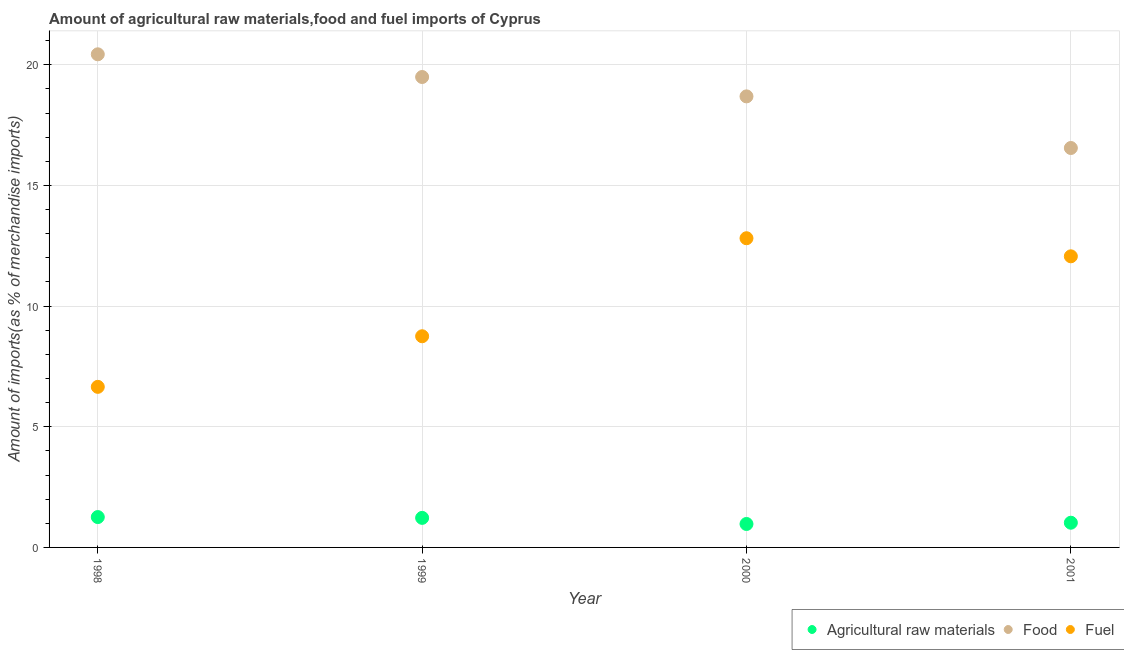Is the number of dotlines equal to the number of legend labels?
Your response must be concise. Yes. What is the percentage of fuel imports in 1999?
Give a very brief answer. 8.75. Across all years, what is the maximum percentage of food imports?
Offer a terse response. 20.43. Across all years, what is the minimum percentage of food imports?
Your response must be concise. 16.55. What is the total percentage of fuel imports in the graph?
Offer a terse response. 40.28. What is the difference between the percentage of raw materials imports in 1998 and that in 2000?
Offer a very short reply. 0.29. What is the difference between the percentage of raw materials imports in 1999 and the percentage of fuel imports in 2000?
Provide a succinct answer. -11.59. What is the average percentage of raw materials imports per year?
Provide a short and direct response. 1.12. In the year 1998, what is the difference between the percentage of raw materials imports and percentage of food imports?
Offer a very short reply. -19.18. In how many years, is the percentage of raw materials imports greater than 4 %?
Provide a succinct answer. 0. What is the ratio of the percentage of raw materials imports in 1999 to that in 2000?
Offer a terse response. 1.26. What is the difference between the highest and the second highest percentage of raw materials imports?
Your answer should be very brief. 0.03. What is the difference between the highest and the lowest percentage of fuel imports?
Your answer should be compact. 6.16. In how many years, is the percentage of fuel imports greater than the average percentage of fuel imports taken over all years?
Provide a succinct answer. 2. How many dotlines are there?
Your answer should be compact. 3. How many years are there in the graph?
Your response must be concise. 4. Are the values on the major ticks of Y-axis written in scientific E-notation?
Offer a very short reply. No. Does the graph contain grids?
Give a very brief answer. Yes. Where does the legend appear in the graph?
Your answer should be very brief. Bottom right. How many legend labels are there?
Make the answer very short. 3. What is the title of the graph?
Keep it short and to the point. Amount of agricultural raw materials,food and fuel imports of Cyprus. Does "Maunufacturing" appear as one of the legend labels in the graph?
Provide a short and direct response. No. What is the label or title of the X-axis?
Offer a terse response. Year. What is the label or title of the Y-axis?
Ensure brevity in your answer.  Amount of imports(as % of merchandise imports). What is the Amount of imports(as % of merchandise imports) in Agricultural raw materials in 1998?
Make the answer very short. 1.26. What is the Amount of imports(as % of merchandise imports) in Food in 1998?
Make the answer very short. 20.43. What is the Amount of imports(as % of merchandise imports) in Fuel in 1998?
Give a very brief answer. 6.65. What is the Amount of imports(as % of merchandise imports) of Agricultural raw materials in 1999?
Make the answer very short. 1.22. What is the Amount of imports(as % of merchandise imports) of Food in 1999?
Offer a very short reply. 19.49. What is the Amount of imports(as % of merchandise imports) of Fuel in 1999?
Make the answer very short. 8.75. What is the Amount of imports(as % of merchandise imports) in Agricultural raw materials in 2000?
Provide a short and direct response. 0.97. What is the Amount of imports(as % of merchandise imports) of Food in 2000?
Your answer should be compact. 18.69. What is the Amount of imports(as % of merchandise imports) of Fuel in 2000?
Offer a terse response. 12.81. What is the Amount of imports(as % of merchandise imports) in Agricultural raw materials in 2001?
Offer a very short reply. 1.02. What is the Amount of imports(as % of merchandise imports) in Food in 2001?
Your answer should be very brief. 16.55. What is the Amount of imports(as % of merchandise imports) of Fuel in 2001?
Give a very brief answer. 12.06. Across all years, what is the maximum Amount of imports(as % of merchandise imports) of Agricultural raw materials?
Your response must be concise. 1.26. Across all years, what is the maximum Amount of imports(as % of merchandise imports) in Food?
Offer a terse response. 20.43. Across all years, what is the maximum Amount of imports(as % of merchandise imports) in Fuel?
Your answer should be compact. 12.81. Across all years, what is the minimum Amount of imports(as % of merchandise imports) of Agricultural raw materials?
Your answer should be compact. 0.97. Across all years, what is the minimum Amount of imports(as % of merchandise imports) of Food?
Your answer should be very brief. 16.55. Across all years, what is the minimum Amount of imports(as % of merchandise imports) of Fuel?
Your answer should be very brief. 6.65. What is the total Amount of imports(as % of merchandise imports) of Agricultural raw materials in the graph?
Keep it short and to the point. 4.48. What is the total Amount of imports(as % of merchandise imports) in Food in the graph?
Offer a very short reply. 75.17. What is the total Amount of imports(as % of merchandise imports) of Fuel in the graph?
Your answer should be compact. 40.28. What is the difference between the Amount of imports(as % of merchandise imports) of Agricultural raw materials in 1998 and that in 1999?
Provide a short and direct response. 0.03. What is the difference between the Amount of imports(as % of merchandise imports) in Food in 1998 and that in 1999?
Your answer should be compact. 0.94. What is the difference between the Amount of imports(as % of merchandise imports) in Fuel in 1998 and that in 1999?
Keep it short and to the point. -2.1. What is the difference between the Amount of imports(as % of merchandise imports) of Agricultural raw materials in 1998 and that in 2000?
Keep it short and to the point. 0.29. What is the difference between the Amount of imports(as % of merchandise imports) of Food in 1998 and that in 2000?
Provide a succinct answer. 1.74. What is the difference between the Amount of imports(as % of merchandise imports) in Fuel in 1998 and that in 2000?
Your answer should be very brief. -6.16. What is the difference between the Amount of imports(as % of merchandise imports) in Agricultural raw materials in 1998 and that in 2001?
Offer a terse response. 0.23. What is the difference between the Amount of imports(as % of merchandise imports) in Food in 1998 and that in 2001?
Provide a succinct answer. 3.88. What is the difference between the Amount of imports(as % of merchandise imports) in Fuel in 1998 and that in 2001?
Offer a very short reply. -5.41. What is the difference between the Amount of imports(as % of merchandise imports) in Agricultural raw materials in 1999 and that in 2000?
Your answer should be compact. 0.25. What is the difference between the Amount of imports(as % of merchandise imports) in Food in 1999 and that in 2000?
Provide a short and direct response. 0.8. What is the difference between the Amount of imports(as % of merchandise imports) in Fuel in 1999 and that in 2000?
Ensure brevity in your answer.  -4.06. What is the difference between the Amount of imports(as % of merchandise imports) in Agricultural raw materials in 1999 and that in 2001?
Your response must be concise. 0.2. What is the difference between the Amount of imports(as % of merchandise imports) of Food in 1999 and that in 2001?
Provide a short and direct response. 2.94. What is the difference between the Amount of imports(as % of merchandise imports) of Fuel in 1999 and that in 2001?
Your answer should be very brief. -3.31. What is the difference between the Amount of imports(as % of merchandise imports) of Agricultural raw materials in 2000 and that in 2001?
Offer a terse response. -0.05. What is the difference between the Amount of imports(as % of merchandise imports) in Food in 2000 and that in 2001?
Your answer should be compact. 2.14. What is the difference between the Amount of imports(as % of merchandise imports) in Fuel in 2000 and that in 2001?
Offer a terse response. 0.75. What is the difference between the Amount of imports(as % of merchandise imports) of Agricultural raw materials in 1998 and the Amount of imports(as % of merchandise imports) of Food in 1999?
Give a very brief answer. -18.24. What is the difference between the Amount of imports(as % of merchandise imports) of Agricultural raw materials in 1998 and the Amount of imports(as % of merchandise imports) of Fuel in 1999?
Provide a succinct answer. -7.49. What is the difference between the Amount of imports(as % of merchandise imports) of Food in 1998 and the Amount of imports(as % of merchandise imports) of Fuel in 1999?
Provide a succinct answer. 11.68. What is the difference between the Amount of imports(as % of merchandise imports) of Agricultural raw materials in 1998 and the Amount of imports(as % of merchandise imports) of Food in 2000?
Provide a succinct answer. -17.43. What is the difference between the Amount of imports(as % of merchandise imports) in Agricultural raw materials in 1998 and the Amount of imports(as % of merchandise imports) in Fuel in 2000?
Your answer should be compact. -11.55. What is the difference between the Amount of imports(as % of merchandise imports) of Food in 1998 and the Amount of imports(as % of merchandise imports) of Fuel in 2000?
Keep it short and to the point. 7.62. What is the difference between the Amount of imports(as % of merchandise imports) of Agricultural raw materials in 1998 and the Amount of imports(as % of merchandise imports) of Food in 2001?
Offer a very short reply. -15.29. What is the difference between the Amount of imports(as % of merchandise imports) of Agricultural raw materials in 1998 and the Amount of imports(as % of merchandise imports) of Fuel in 2001?
Offer a terse response. -10.8. What is the difference between the Amount of imports(as % of merchandise imports) of Food in 1998 and the Amount of imports(as % of merchandise imports) of Fuel in 2001?
Make the answer very short. 8.37. What is the difference between the Amount of imports(as % of merchandise imports) of Agricultural raw materials in 1999 and the Amount of imports(as % of merchandise imports) of Food in 2000?
Keep it short and to the point. -17.47. What is the difference between the Amount of imports(as % of merchandise imports) of Agricultural raw materials in 1999 and the Amount of imports(as % of merchandise imports) of Fuel in 2000?
Keep it short and to the point. -11.59. What is the difference between the Amount of imports(as % of merchandise imports) of Food in 1999 and the Amount of imports(as % of merchandise imports) of Fuel in 2000?
Give a very brief answer. 6.68. What is the difference between the Amount of imports(as % of merchandise imports) in Agricultural raw materials in 1999 and the Amount of imports(as % of merchandise imports) in Food in 2001?
Give a very brief answer. -15.33. What is the difference between the Amount of imports(as % of merchandise imports) in Agricultural raw materials in 1999 and the Amount of imports(as % of merchandise imports) in Fuel in 2001?
Provide a succinct answer. -10.84. What is the difference between the Amount of imports(as % of merchandise imports) of Food in 1999 and the Amount of imports(as % of merchandise imports) of Fuel in 2001?
Make the answer very short. 7.43. What is the difference between the Amount of imports(as % of merchandise imports) in Agricultural raw materials in 2000 and the Amount of imports(as % of merchandise imports) in Food in 2001?
Your answer should be compact. -15.58. What is the difference between the Amount of imports(as % of merchandise imports) in Agricultural raw materials in 2000 and the Amount of imports(as % of merchandise imports) in Fuel in 2001?
Make the answer very short. -11.09. What is the difference between the Amount of imports(as % of merchandise imports) of Food in 2000 and the Amount of imports(as % of merchandise imports) of Fuel in 2001?
Keep it short and to the point. 6.63. What is the average Amount of imports(as % of merchandise imports) of Agricultural raw materials per year?
Your answer should be compact. 1.12. What is the average Amount of imports(as % of merchandise imports) of Food per year?
Ensure brevity in your answer.  18.79. What is the average Amount of imports(as % of merchandise imports) of Fuel per year?
Your response must be concise. 10.07. In the year 1998, what is the difference between the Amount of imports(as % of merchandise imports) of Agricultural raw materials and Amount of imports(as % of merchandise imports) of Food?
Offer a terse response. -19.18. In the year 1998, what is the difference between the Amount of imports(as % of merchandise imports) of Agricultural raw materials and Amount of imports(as % of merchandise imports) of Fuel?
Ensure brevity in your answer.  -5.4. In the year 1998, what is the difference between the Amount of imports(as % of merchandise imports) of Food and Amount of imports(as % of merchandise imports) of Fuel?
Ensure brevity in your answer.  13.78. In the year 1999, what is the difference between the Amount of imports(as % of merchandise imports) in Agricultural raw materials and Amount of imports(as % of merchandise imports) in Food?
Make the answer very short. -18.27. In the year 1999, what is the difference between the Amount of imports(as % of merchandise imports) in Agricultural raw materials and Amount of imports(as % of merchandise imports) in Fuel?
Keep it short and to the point. -7.53. In the year 1999, what is the difference between the Amount of imports(as % of merchandise imports) in Food and Amount of imports(as % of merchandise imports) in Fuel?
Provide a succinct answer. 10.74. In the year 2000, what is the difference between the Amount of imports(as % of merchandise imports) in Agricultural raw materials and Amount of imports(as % of merchandise imports) in Food?
Ensure brevity in your answer.  -17.72. In the year 2000, what is the difference between the Amount of imports(as % of merchandise imports) in Agricultural raw materials and Amount of imports(as % of merchandise imports) in Fuel?
Provide a short and direct response. -11.84. In the year 2000, what is the difference between the Amount of imports(as % of merchandise imports) in Food and Amount of imports(as % of merchandise imports) in Fuel?
Give a very brief answer. 5.88. In the year 2001, what is the difference between the Amount of imports(as % of merchandise imports) of Agricultural raw materials and Amount of imports(as % of merchandise imports) of Food?
Make the answer very short. -15.53. In the year 2001, what is the difference between the Amount of imports(as % of merchandise imports) in Agricultural raw materials and Amount of imports(as % of merchandise imports) in Fuel?
Offer a terse response. -11.04. In the year 2001, what is the difference between the Amount of imports(as % of merchandise imports) of Food and Amount of imports(as % of merchandise imports) of Fuel?
Ensure brevity in your answer.  4.49. What is the ratio of the Amount of imports(as % of merchandise imports) of Agricultural raw materials in 1998 to that in 1999?
Provide a succinct answer. 1.03. What is the ratio of the Amount of imports(as % of merchandise imports) in Food in 1998 to that in 1999?
Your response must be concise. 1.05. What is the ratio of the Amount of imports(as % of merchandise imports) of Fuel in 1998 to that in 1999?
Give a very brief answer. 0.76. What is the ratio of the Amount of imports(as % of merchandise imports) in Agricultural raw materials in 1998 to that in 2000?
Give a very brief answer. 1.3. What is the ratio of the Amount of imports(as % of merchandise imports) in Food in 1998 to that in 2000?
Give a very brief answer. 1.09. What is the ratio of the Amount of imports(as % of merchandise imports) in Fuel in 1998 to that in 2000?
Offer a terse response. 0.52. What is the ratio of the Amount of imports(as % of merchandise imports) of Agricultural raw materials in 1998 to that in 2001?
Your response must be concise. 1.23. What is the ratio of the Amount of imports(as % of merchandise imports) in Food in 1998 to that in 2001?
Your answer should be very brief. 1.23. What is the ratio of the Amount of imports(as % of merchandise imports) of Fuel in 1998 to that in 2001?
Keep it short and to the point. 0.55. What is the ratio of the Amount of imports(as % of merchandise imports) in Agricultural raw materials in 1999 to that in 2000?
Offer a terse response. 1.26. What is the ratio of the Amount of imports(as % of merchandise imports) of Food in 1999 to that in 2000?
Provide a succinct answer. 1.04. What is the ratio of the Amount of imports(as % of merchandise imports) of Fuel in 1999 to that in 2000?
Your response must be concise. 0.68. What is the ratio of the Amount of imports(as % of merchandise imports) of Agricultural raw materials in 1999 to that in 2001?
Give a very brief answer. 1.2. What is the ratio of the Amount of imports(as % of merchandise imports) in Food in 1999 to that in 2001?
Offer a terse response. 1.18. What is the ratio of the Amount of imports(as % of merchandise imports) of Fuel in 1999 to that in 2001?
Keep it short and to the point. 0.73. What is the ratio of the Amount of imports(as % of merchandise imports) of Agricultural raw materials in 2000 to that in 2001?
Your answer should be very brief. 0.95. What is the ratio of the Amount of imports(as % of merchandise imports) of Food in 2000 to that in 2001?
Your answer should be very brief. 1.13. What is the ratio of the Amount of imports(as % of merchandise imports) in Fuel in 2000 to that in 2001?
Offer a very short reply. 1.06. What is the difference between the highest and the second highest Amount of imports(as % of merchandise imports) of Agricultural raw materials?
Your answer should be very brief. 0.03. What is the difference between the highest and the second highest Amount of imports(as % of merchandise imports) in Food?
Your response must be concise. 0.94. What is the difference between the highest and the second highest Amount of imports(as % of merchandise imports) of Fuel?
Keep it short and to the point. 0.75. What is the difference between the highest and the lowest Amount of imports(as % of merchandise imports) of Agricultural raw materials?
Offer a terse response. 0.29. What is the difference between the highest and the lowest Amount of imports(as % of merchandise imports) in Food?
Provide a short and direct response. 3.88. What is the difference between the highest and the lowest Amount of imports(as % of merchandise imports) of Fuel?
Provide a short and direct response. 6.16. 